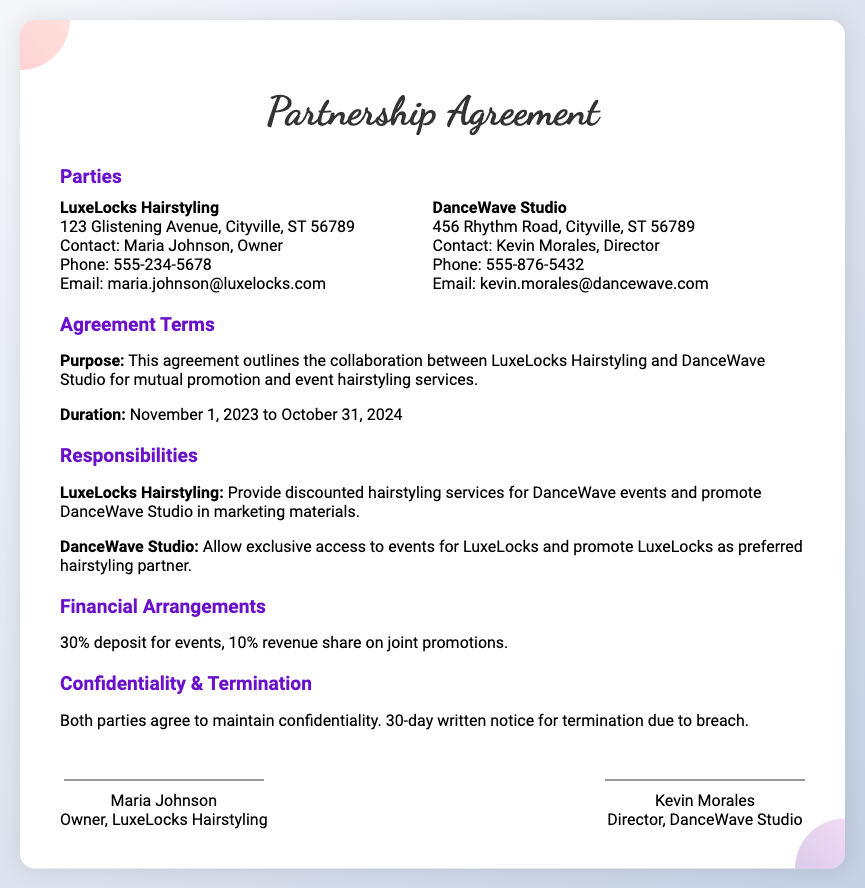What is the name of the hairstyling business? The document states the name of the hairstyling business as LuxeLocks Hairstyling.
Answer: LuxeLocks Hairstyling Who is the owner of LuxeLocks Hairstyling? The document specifies that Maria Johnson is the owner of LuxeLocks Hairstyling.
Answer: Maria Johnson What is the duration of the agreement? The duration specified in the document is from November 1, 2023 to October 31, 2024.
Answer: November 1, 2023 to October 31, 2024 What percentage of revenue share does LuxeLocks receive from joint promotions? The document mentions a 10% revenue share on joint promotions.
Answer: 10% What services will LuxeLocks provide for DanceWave events? The document outlines that LuxeLocks will provide discounted hairstyling services for DanceWave events.
Answer: Discounted hairstyling services What notice period is required for termination due to breach? The document states a 30-day written notice is required for termination due to breach.
Answer: 30 days What is DanceWave Studio's responsibility related to LuxeLocks? DanceWave Studio is required to promote LuxeLocks as the preferred hairstyling partner.
Answer: Promote LuxeLocks as preferred hairstyling partner What is the deposit required for events? The document details that a 30% deposit is required for events.
Answer: 30% Who is the director of DanceWave Studio? The document provides the name of the dance studio's director as Kevin Morales.
Answer: Kevin Morales 